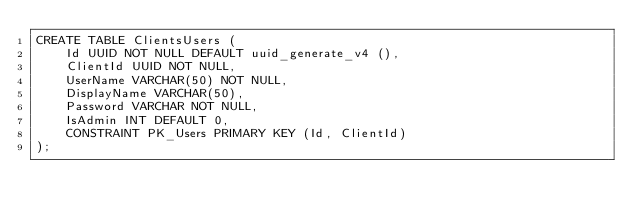Convert code to text. <code><loc_0><loc_0><loc_500><loc_500><_SQL_>CREATE TABLE ClientsUsers (
    Id UUID NOT NULL DEFAULT uuid_generate_v4 (),
    ClientId UUID NOT NULL,
    UserName VARCHAR(50) NOT NULL,
    DisplayName VARCHAR(50),
    Password VARCHAR NOT NULL,
    IsAdmin INT DEFAULT 0,
    CONSTRAINT PK_Users PRIMARY KEY (Id, ClientId)
);</code> 